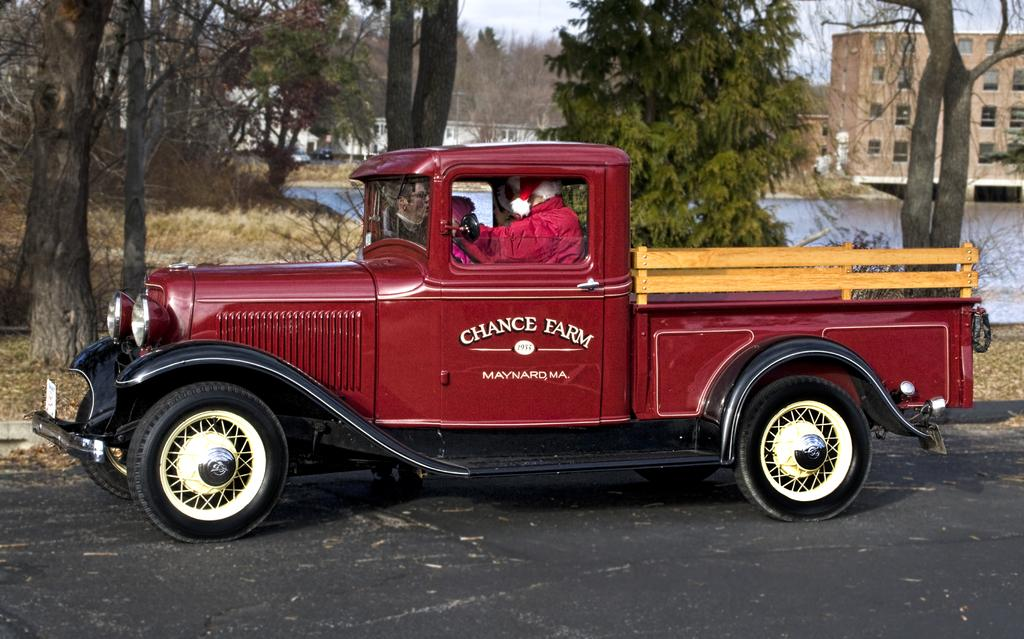What is the man doing in the image? The man is sitting inside a red car. What can be seen in the background of the image? There are trees, plants, grass, a bridge, and a building in the background of the image. What is at the bottom of the image? There is a road at the bottom of the image. Where is the tub located in the image? There is no tub present in the image. Can you describe the haircut of the man in the image? The image does not show the man's haircut, as it only shows him sitting in the car. 